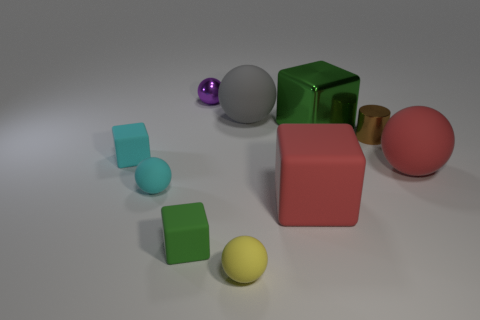Imagine if these objects were characters in a story, what kind of story could they be in? If these objects were characters in a story, they could belong to a whimsical tale set in a mysterious, geometric land. The green block could be the wise elder, the pink sphere could be the kind-hearted protagonist, and the tiny purple ball could be the curious sidekick. The metallic cylinder might be an ancient relic or portal, while the cyan cubes could be loyal companions or stepping stones to some secret location. Together, their story would involve solving puzzles and collaborating to overcome challenges in their cubic world. 